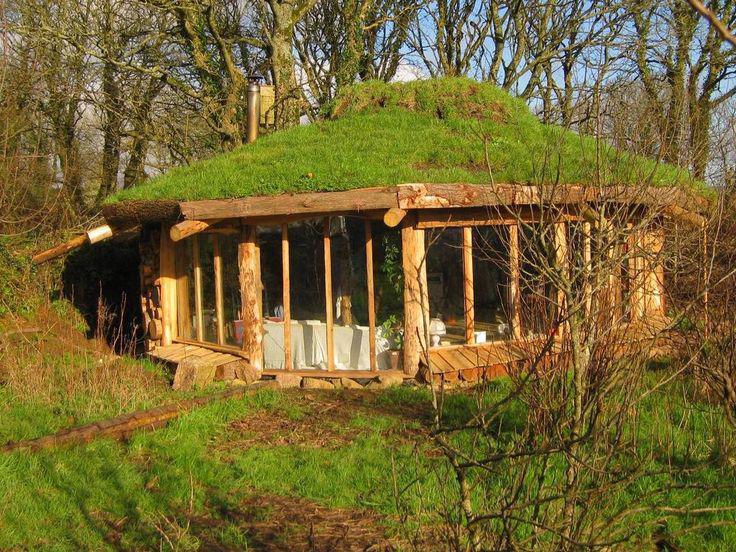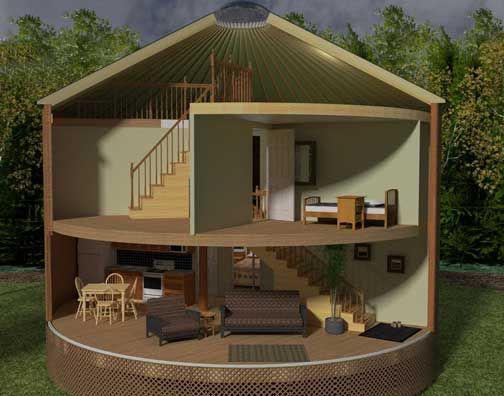The first image is the image on the left, the second image is the image on the right. For the images shown, is this caption "At least one image you can see inside of the house." true? Answer yes or no. Yes. 